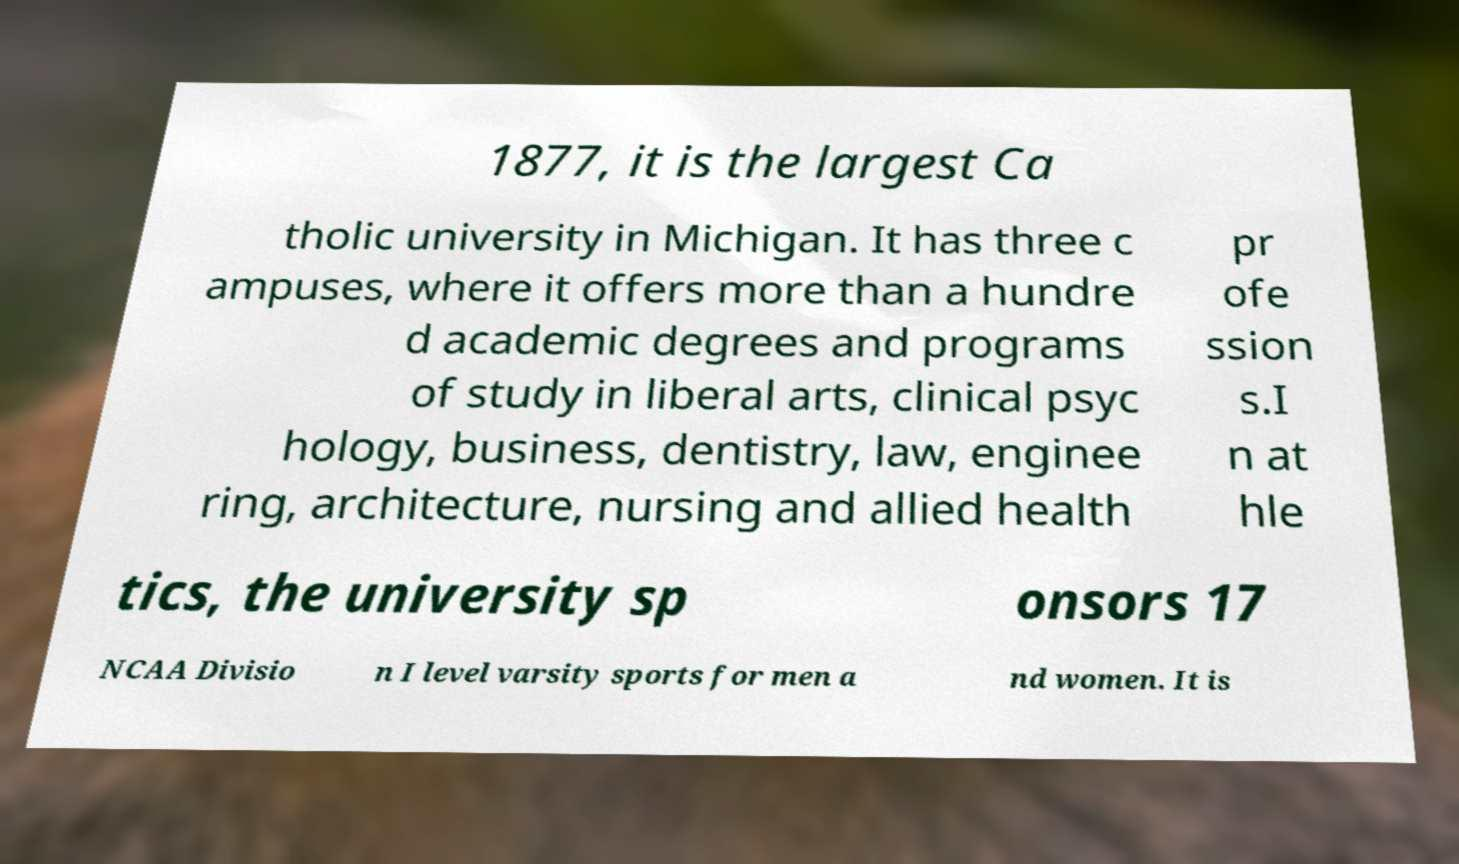Please identify and transcribe the text found in this image. 1877, it is the largest Ca tholic university in Michigan. It has three c ampuses, where it offers more than a hundre d academic degrees and programs of study in liberal arts, clinical psyc hology, business, dentistry, law, enginee ring, architecture, nursing and allied health pr ofe ssion s.I n at hle tics, the university sp onsors 17 NCAA Divisio n I level varsity sports for men a nd women. It is 